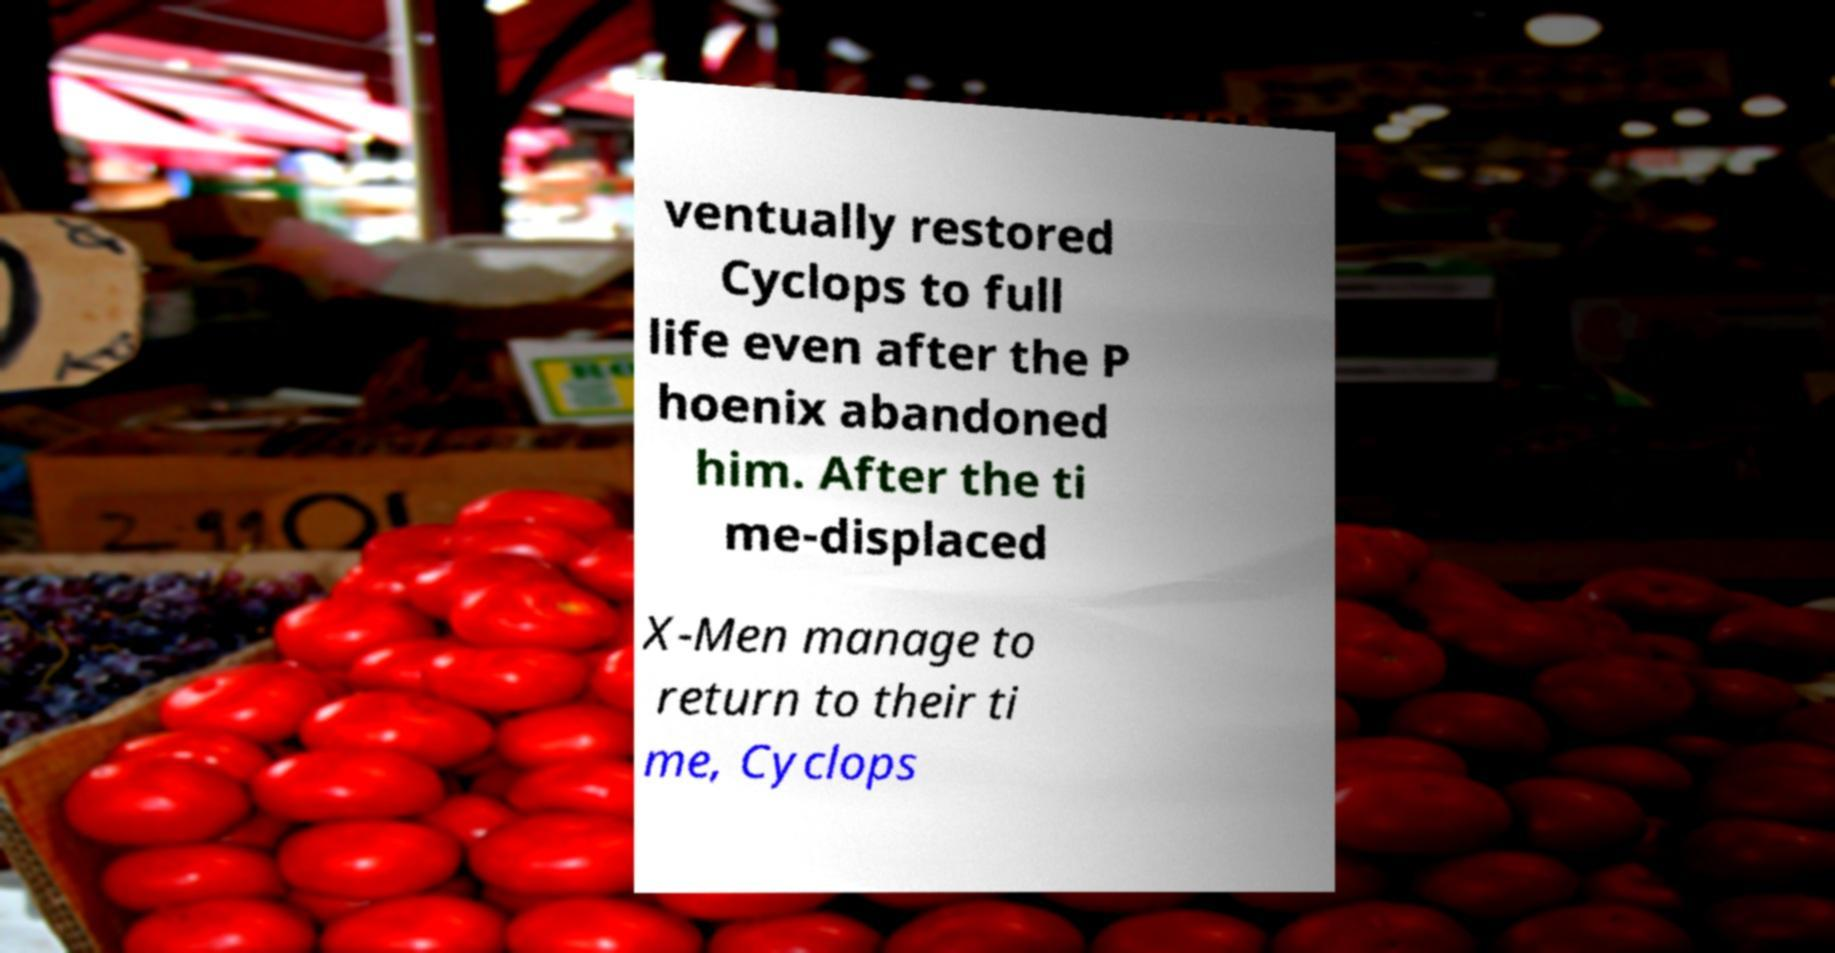What messages or text are displayed in this image? I need them in a readable, typed format. ventually restored Cyclops to full life even after the P hoenix abandoned him. After the ti me-displaced X-Men manage to return to their ti me, Cyclops 